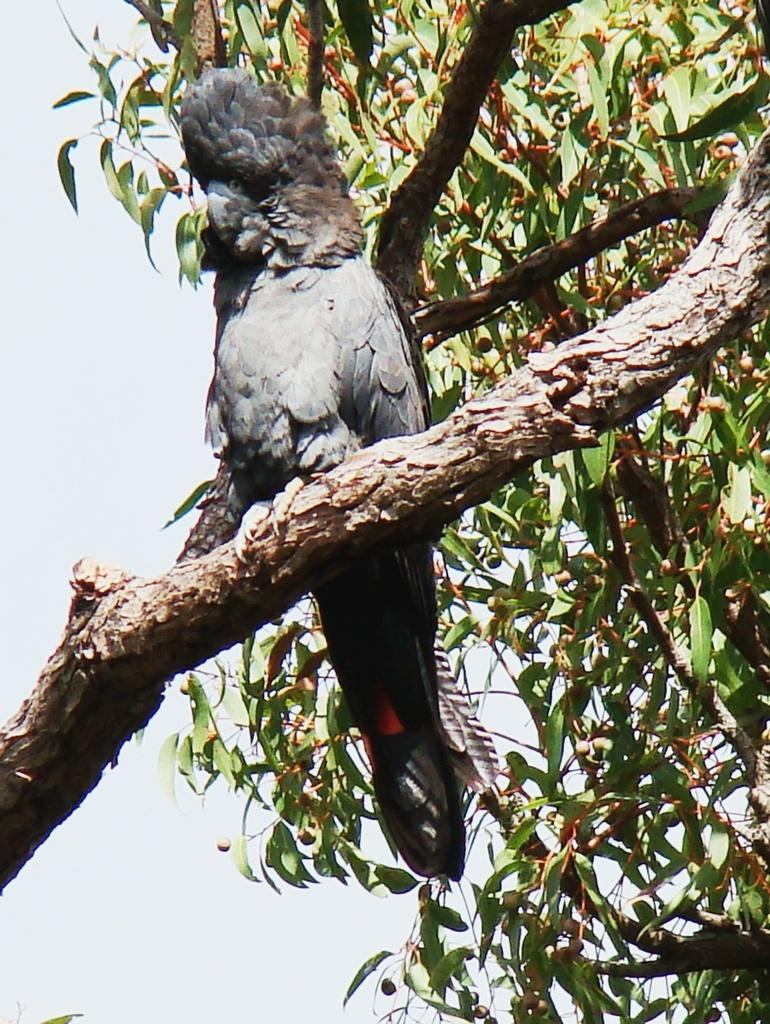What type of animal can be seen in the image? There is a bird in the image. Where is the bird located? The bird is standing on a branch of a tree. What can be seen in the right corner of the image? There are leaves visible in the right corner of the image. What type of road can be seen in the image? There is no road present in the image; it features a bird on a tree branch. What kind of beast is depicted in the image? There is no beast present in the image; it features a bird on a tree branch. 